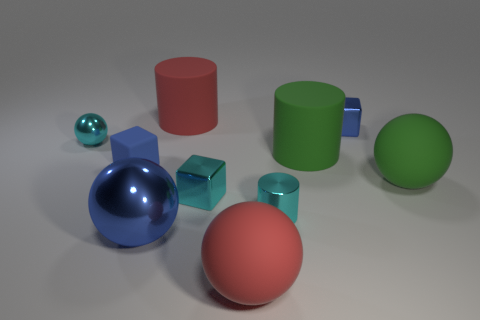Subtract all green balls. How many balls are left? 3 Subtract all tiny cyan cylinders. How many cylinders are left? 2 Subtract all cubes. How many objects are left? 7 Subtract 3 spheres. How many spheres are left? 1 Subtract all cyan spheres. How many blue blocks are left? 2 Add 3 cyan things. How many cyan things are left? 6 Add 3 large red matte things. How many large red matte things exist? 5 Subtract 0 gray cylinders. How many objects are left? 10 Subtract all green blocks. Subtract all red spheres. How many blocks are left? 3 Subtract all rubber things. Subtract all tiny blue metallic spheres. How many objects are left? 5 